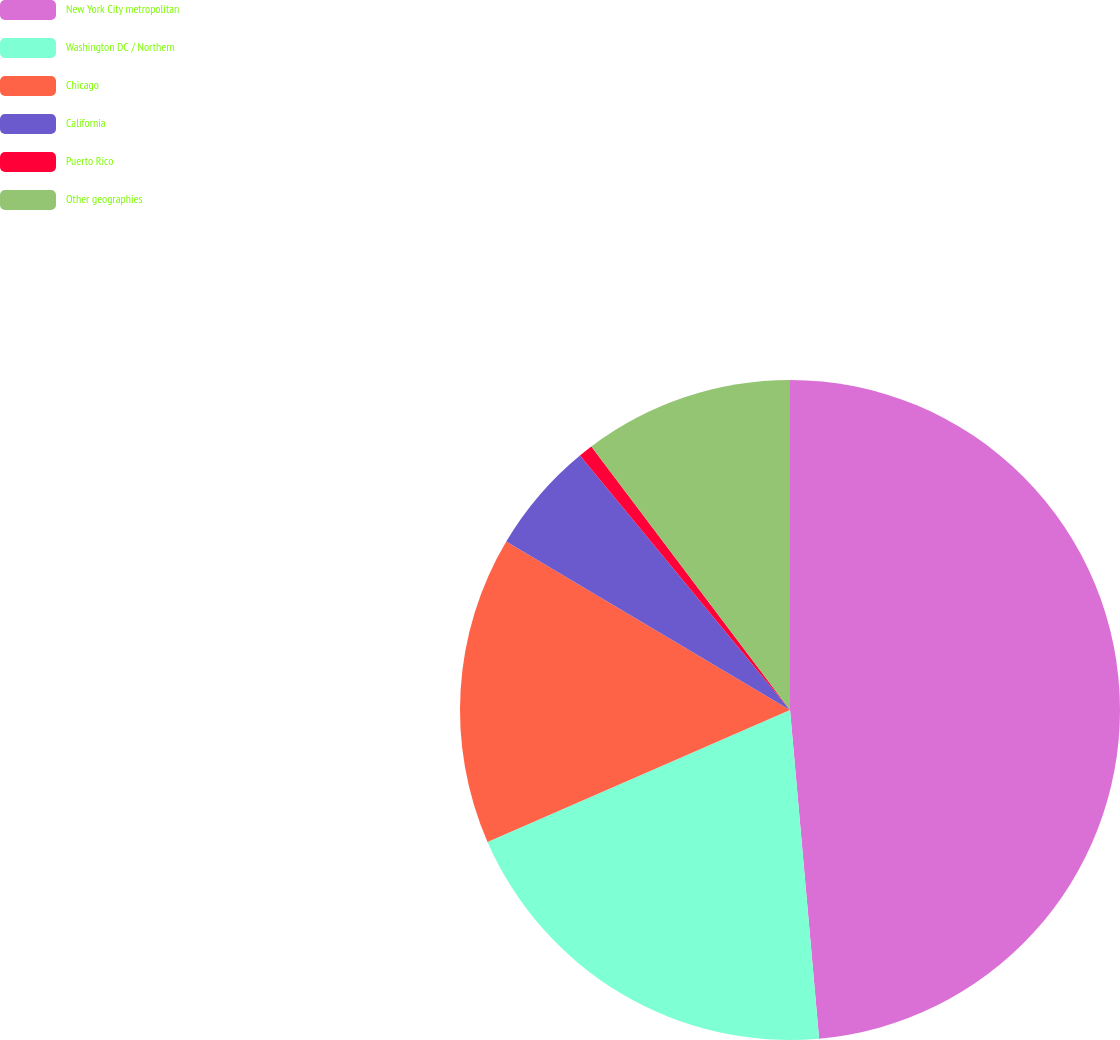Convert chart to OTSL. <chart><loc_0><loc_0><loc_500><loc_500><pie_chart><fcel>New York City metropolitan<fcel>Washington DC / Northern<fcel>Chicago<fcel>California<fcel>Puerto Rico<fcel>Other geographies<nl><fcel>48.59%<fcel>19.86%<fcel>15.07%<fcel>5.49%<fcel>0.7%<fcel>10.28%<nl></chart> 